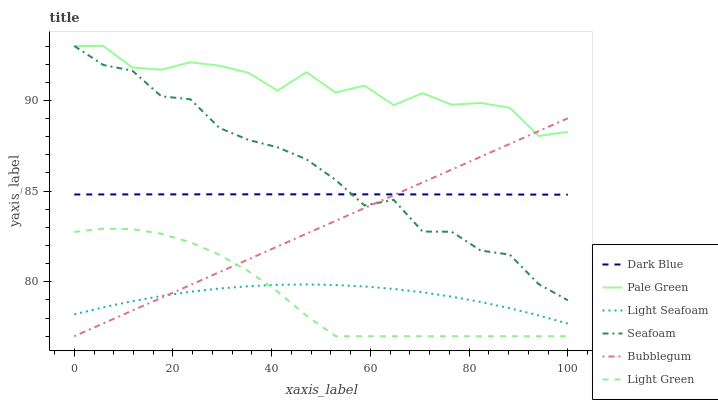Does Light Green have the minimum area under the curve?
Answer yes or no. Yes. Does Pale Green have the maximum area under the curve?
Answer yes or no. Yes. Does Bubblegum have the minimum area under the curve?
Answer yes or no. No. Does Bubblegum have the maximum area under the curve?
Answer yes or no. No. Is Bubblegum the smoothest?
Answer yes or no. Yes. Is Pale Green the roughest?
Answer yes or no. Yes. Is Dark Blue the smoothest?
Answer yes or no. No. Is Dark Blue the roughest?
Answer yes or no. No. Does Bubblegum have the lowest value?
Answer yes or no. Yes. Does Dark Blue have the lowest value?
Answer yes or no. No. Does Pale Green have the highest value?
Answer yes or no. Yes. Does Bubblegum have the highest value?
Answer yes or no. No. Is Light Seafoam less than Seafoam?
Answer yes or no. Yes. Is Pale Green greater than Dark Blue?
Answer yes or no. Yes. Does Dark Blue intersect Seafoam?
Answer yes or no. Yes. Is Dark Blue less than Seafoam?
Answer yes or no. No. Is Dark Blue greater than Seafoam?
Answer yes or no. No. Does Light Seafoam intersect Seafoam?
Answer yes or no. No. 